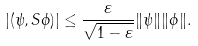Convert formula to latex. <formula><loc_0><loc_0><loc_500><loc_500>| ( \psi , S \phi ) | \leq \frac { \varepsilon } { \sqrt { 1 - \varepsilon } } \| \psi \| \| \phi \| .</formula> 